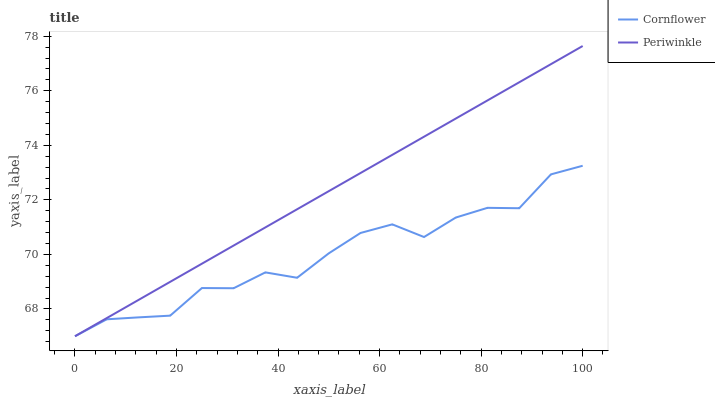Does Cornflower have the minimum area under the curve?
Answer yes or no. Yes. Does Periwinkle have the maximum area under the curve?
Answer yes or no. Yes. Does Periwinkle have the minimum area under the curve?
Answer yes or no. No. Is Periwinkle the smoothest?
Answer yes or no. Yes. Is Cornflower the roughest?
Answer yes or no. Yes. Is Periwinkle the roughest?
Answer yes or no. No. Does Cornflower have the lowest value?
Answer yes or no. Yes. Does Periwinkle have the highest value?
Answer yes or no. Yes. Does Cornflower intersect Periwinkle?
Answer yes or no. Yes. Is Cornflower less than Periwinkle?
Answer yes or no. No. Is Cornflower greater than Periwinkle?
Answer yes or no. No. 